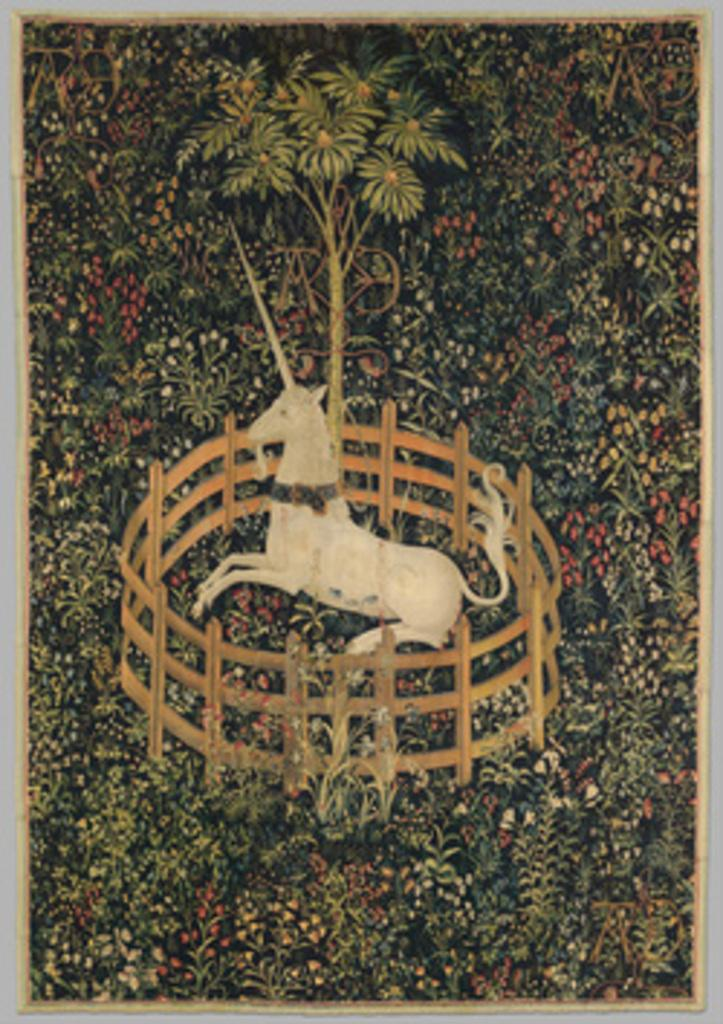What is depicted in the photo frame in the image? There is a photo frame of a horse in the image. Where is the photo frame located? The photo frame is in a fence. What type of natural element is visible in the image? There is a tree visible in the image. Can you tell me how many teeth the horse in the photo frame has? The horse in the photo frame is a two-dimensional image, so it does not have teeth. Is there a lake visible in the image? There is no lake present in the image. 